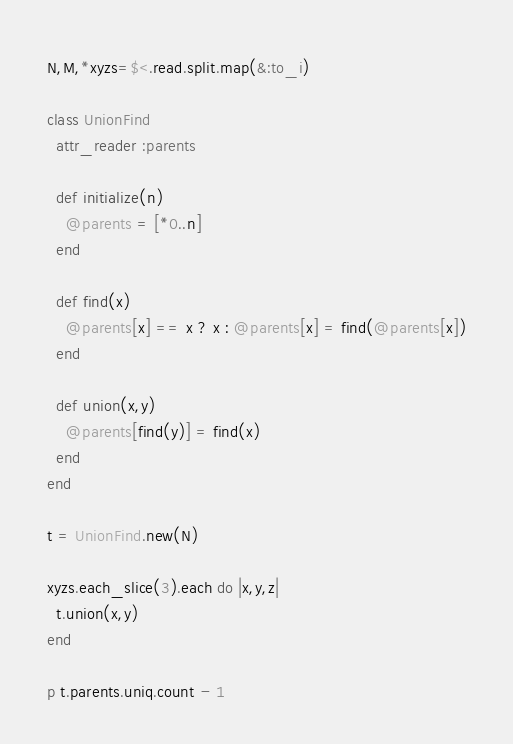<code> <loc_0><loc_0><loc_500><loc_500><_Ruby_>N,M,*xyzs=$<.read.split.map(&:to_i)

class UnionFind
  attr_reader :parents

  def initialize(n)
    @parents = [*0..n]
  end

  def find(x)
    @parents[x] == x ? x : @parents[x] = find(@parents[x])
  end

  def union(x,y)
    @parents[find(y)] = find(x)
  end
end

t = UnionFind.new(N)

xyzs.each_slice(3).each do |x,y,z|
  t.union(x,y)
end

p t.parents.uniq.count - 1


</code> 